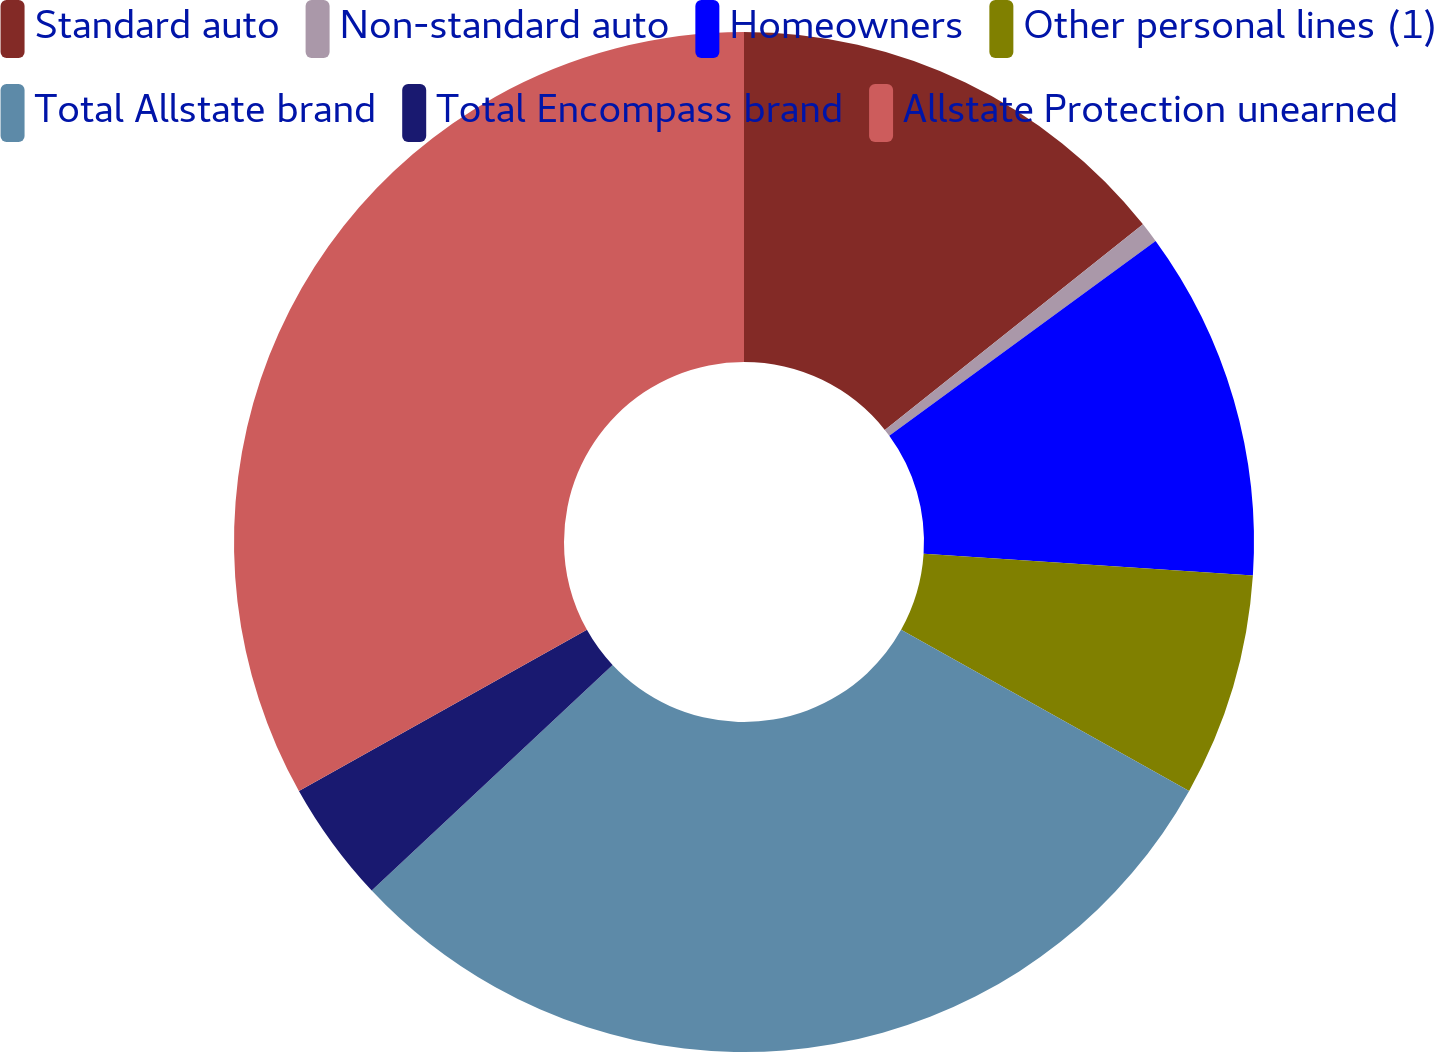<chart> <loc_0><loc_0><loc_500><loc_500><pie_chart><fcel>Standard auto<fcel>Non-standard auto<fcel>Homeowners<fcel>Other personal lines (1)<fcel>Total Allstate brand<fcel>Total Encompass brand<fcel>Allstate Protection unearned<nl><fcel>14.3%<fcel>0.65%<fcel>11.1%<fcel>7.07%<fcel>29.91%<fcel>3.86%<fcel>33.12%<nl></chart> 